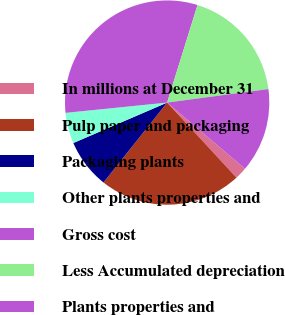Convert chart. <chart><loc_0><loc_0><loc_500><loc_500><pie_chart><fcel>In millions at December 31<fcel>Pulp paper and packaging<fcel>Packaging plants<fcel>Other plants properties and<fcel>Gross cost<fcel>Less Accumulated depreciation<fcel>Plants properties and<nl><fcel>1.92%<fcel>22.57%<fcel>7.82%<fcel>4.87%<fcel>31.41%<fcel>18.09%<fcel>13.32%<nl></chart> 